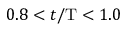<formula> <loc_0><loc_0><loc_500><loc_500>0 . 8 < t / T < 1 . 0</formula> 